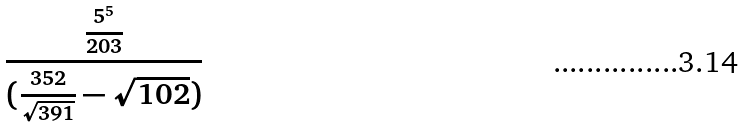Convert formula to latex. <formula><loc_0><loc_0><loc_500><loc_500>\frac { \frac { 5 ^ { 5 } } { 2 0 3 } } { ( \frac { 3 5 2 } { \sqrt { 3 9 1 } } - \sqrt { 1 0 2 } ) }</formula> 